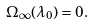<formula> <loc_0><loc_0><loc_500><loc_500>\Omega _ { \infty } ( \lambda _ { 0 } ) = 0 .</formula> 